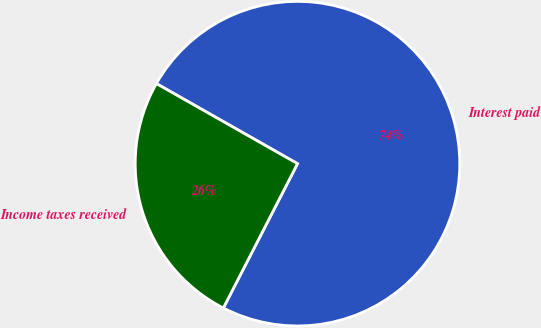<chart> <loc_0><loc_0><loc_500><loc_500><pie_chart><fcel>Interest paid<fcel>Income taxes received<nl><fcel>74.34%<fcel>25.66%<nl></chart> 